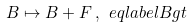<formula> <loc_0><loc_0><loc_500><loc_500>B \mapsto B + F \, , \ e q l a b e l { B g t }</formula> 